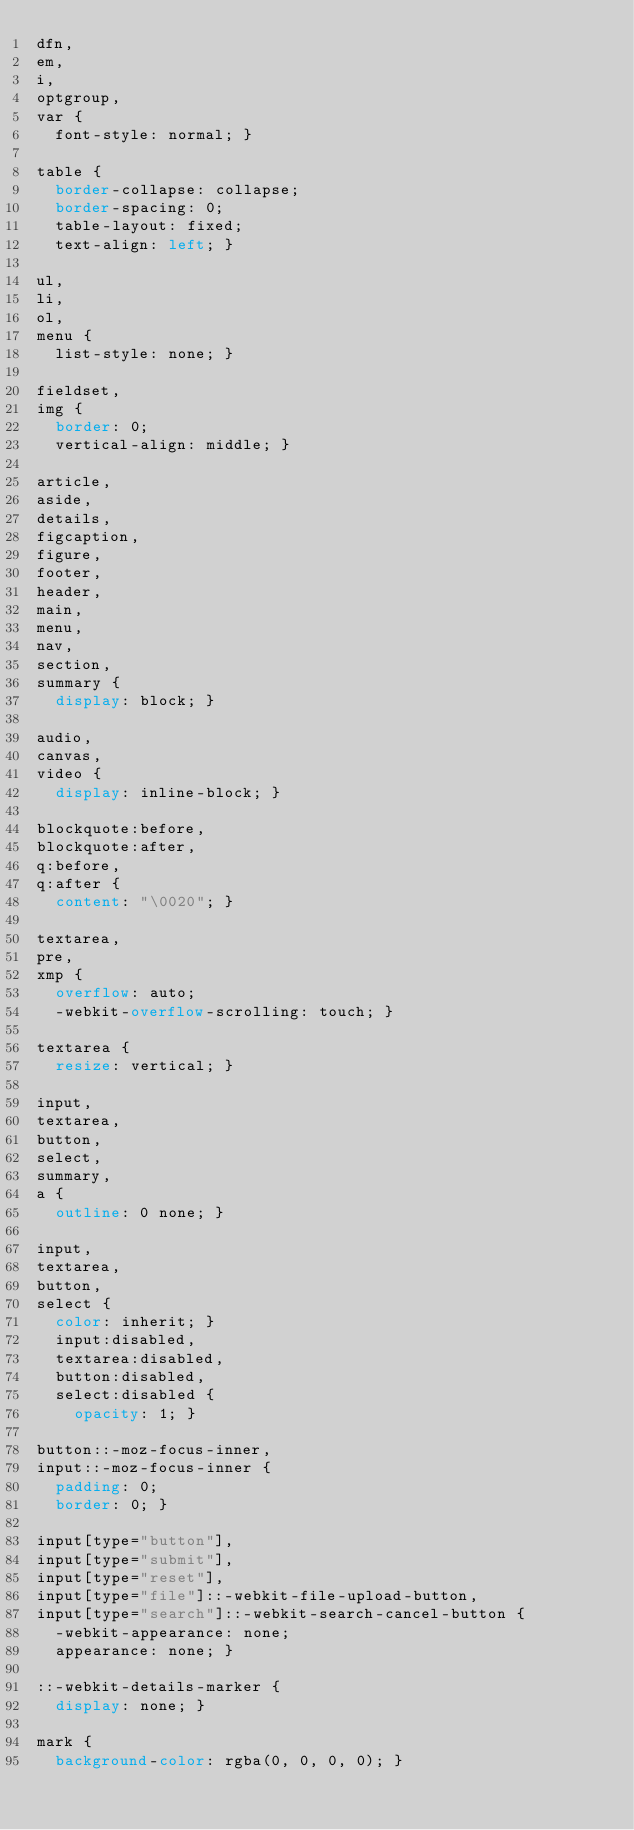Convert code to text. <code><loc_0><loc_0><loc_500><loc_500><_CSS_>dfn,
em,
i,
optgroup,
var {
  font-style: normal; }

table {
  border-collapse: collapse;
  border-spacing: 0;
  table-layout: fixed;
  text-align: left; }

ul,
li,
ol,
menu {
  list-style: none; }

fieldset,
img {
  border: 0;
  vertical-align: middle; }

article,
aside,
details,
figcaption,
figure,
footer,
header,
main,
menu,
nav,
section,
summary {
  display: block; }

audio,
canvas,
video {
  display: inline-block; }

blockquote:before,
blockquote:after,
q:before,
q:after {
  content: "\0020"; }

textarea,
pre,
xmp {
  overflow: auto;
  -webkit-overflow-scrolling: touch; }

textarea {
  resize: vertical; }

input,
textarea,
button,
select,
summary,
a {
  outline: 0 none; }

input,
textarea,
button,
select {
  color: inherit; }
  input:disabled,
  textarea:disabled,
  button:disabled,
  select:disabled {
    opacity: 1; }

button::-moz-focus-inner,
input::-moz-focus-inner {
  padding: 0;
  border: 0; }

input[type="button"],
input[type="submit"],
input[type="reset"],
input[type="file"]::-webkit-file-upload-button,
input[type="search"]::-webkit-search-cancel-button {
  -webkit-appearance: none;
  appearance: none; }

::-webkit-details-marker {
  display: none; }

mark {
  background-color: rgba(0, 0, 0, 0); }
</code> 